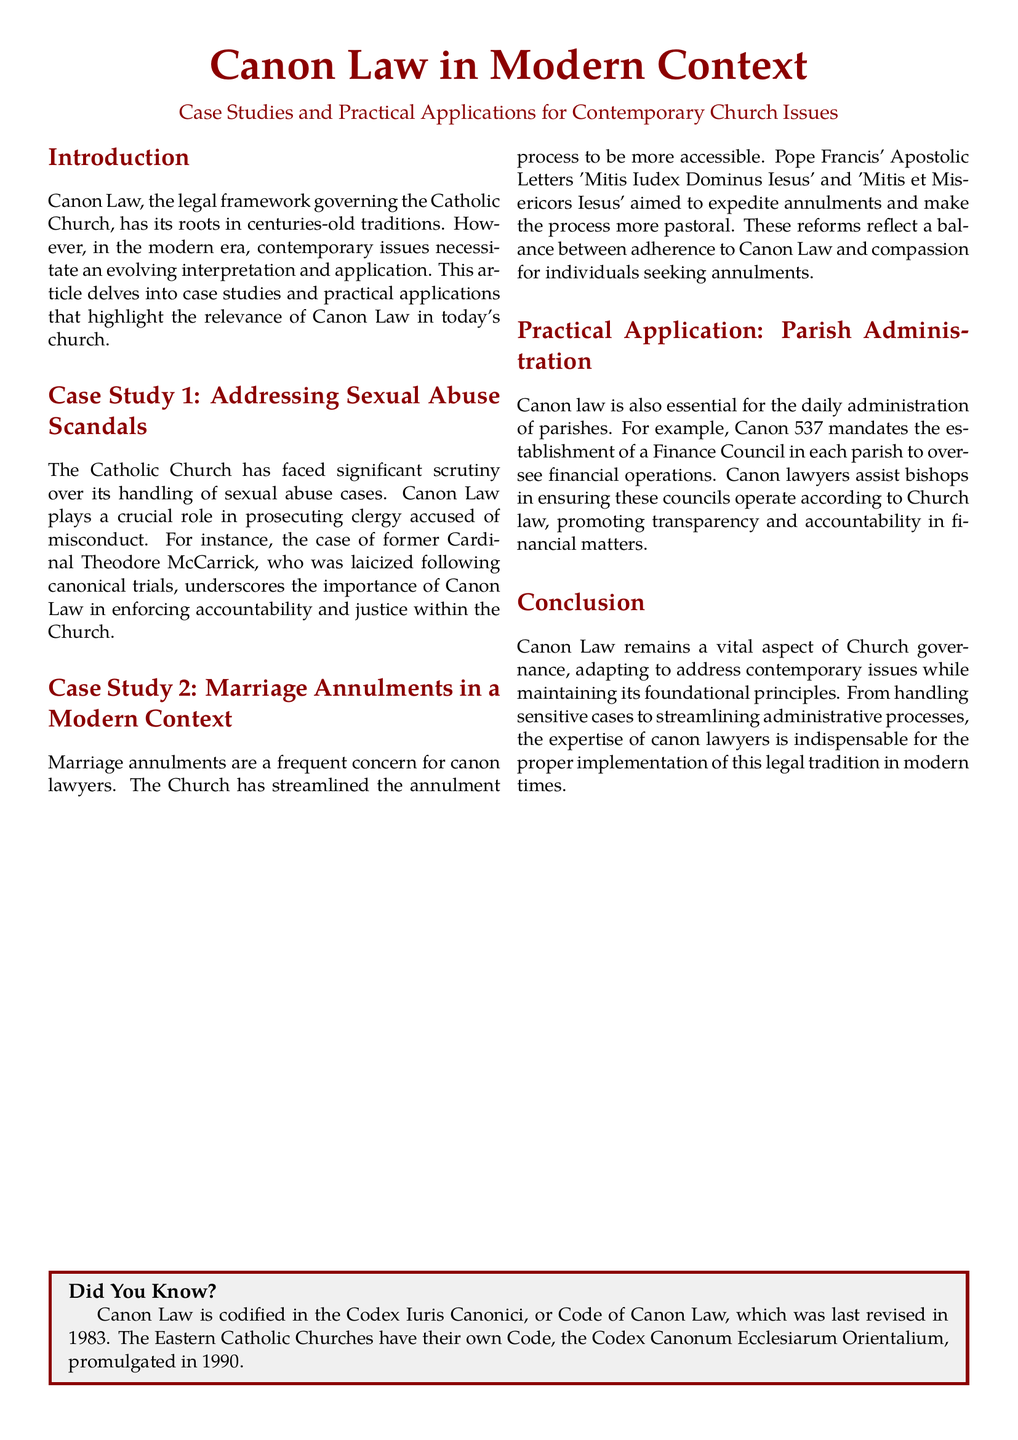What is the title of the document? The title is prominently mentioned at the top of the document.
Answer: Canon Law in Modern Context What issue does Case Study 1 address? Case Study 1 specifically focuses on a significant issue within the Church.
Answer: Sexual Abuse Scandals Who was laicized following canonical trials? The document provides a specific name related to the case in this context.
Answer: Cardinal Theodore McCarrick What are the names of the Apostolic Letters discussed in Case Study 2? These letters are significant reforms highlighted in the document.
Answer: Mitis Iudex Dominus Iesus and Mitis et Misericors Iesus What does Canon 537 mandate? This canon law is specifically related to financial oversight in parishes.
Answer: The establishment of a Finance Council What year was the Codex Iuris Canonici last revised? The document mentions the revision date of the codification.
Answer: 1983 What is the purpose of the Finance Council mentioned in the document? The function of this council is clearly articulated within the document.
Answer: To oversee financial operations What does Canon Law adapt to address? The document outlines the modern challenges faced by Canon Law.
Answer: Contemporary issues What type of law does Canon Law represent? The document categorizes the legal framework governing the Church.
Answer: Legal framework governing the Catholic Church 